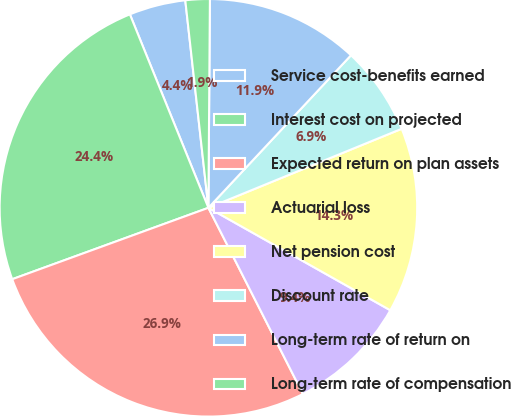<chart> <loc_0><loc_0><loc_500><loc_500><pie_chart><fcel>Service cost-benefits earned<fcel>Interest cost on projected<fcel>Expected return on plan assets<fcel>Actuarial loss<fcel>Net pension cost<fcel>Discount rate<fcel>Long-term rate of return on<fcel>Long-term rate of compensation<nl><fcel>4.37%<fcel>24.42%<fcel>26.92%<fcel>9.36%<fcel>14.34%<fcel>6.86%<fcel>11.85%<fcel>1.88%<nl></chart> 